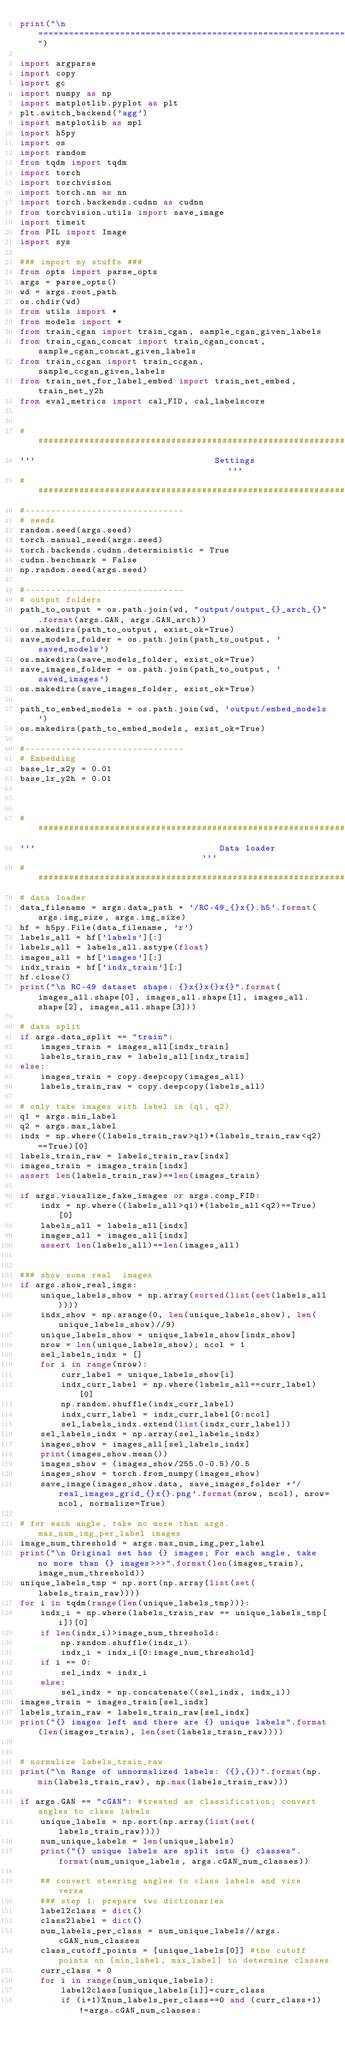Convert code to text. <code><loc_0><loc_0><loc_500><loc_500><_Python_>print("\n===================================================================================================")

import argparse
import copy
import gc
import numpy as np
import matplotlib.pyplot as plt
plt.switch_backend('agg')
import matplotlib as mpl
import h5py
import os
import random
from tqdm import tqdm
import torch
import torchvision
import torch.nn as nn
import torch.backends.cudnn as cudnn
from torchvision.utils import save_image
import timeit
from PIL import Image
import sys

### import my stuffs ###
from opts import parse_opts
args = parse_opts()
wd = args.root_path
os.chdir(wd)
from utils import *
from models import *
from train_cgan import train_cgan, sample_cgan_given_labels
from train_cgan_concat import train_cgan_concat, sample_cgan_concat_given_labels
from train_ccgan import train_ccgan, sample_ccgan_given_labels
from train_net_for_label_embed import train_net_embed, train_net_y2h
from eval_metrics import cal_FID, cal_labelscore


#######################################################################################
'''                                   Settings                                      '''
#######################################################################################
#-------------------------------
# seeds
random.seed(args.seed)
torch.manual_seed(args.seed)
torch.backends.cudnn.deterministic = True
cudnn.benchmark = False
np.random.seed(args.seed)

#-------------------------------
# output folders
path_to_output = os.path.join(wd, "output/output_{}_arch_{}".format(args.GAN, args.GAN_arch))
os.makedirs(path_to_output, exist_ok=True)
save_models_folder = os.path.join(path_to_output, 'saved_models')
os.makedirs(save_models_folder, exist_ok=True)
save_images_folder = os.path.join(path_to_output, 'saved_images')
os.makedirs(save_images_folder, exist_ok=True)

path_to_embed_models = os.path.join(wd, 'output/embed_models')
os.makedirs(path_to_embed_models, exist_ok=True)

#-------------------------------
# Embedding
base_lr_x2y = 0.01
base_lr_y2h = 0.01



#######################################################################################
'''                                    Data loader                                 '''
#######################################################################################
# data loader
data_filename = args.data_path + '/RC-49_{}x{}.h5'.format(args.img_size, args.img_size)
hf = h5py.File(data_filename, 'r')
labels_all = hf['labels'][:]
labels_all = labels_all.astype(float)
images_all = hf['images'][:]
indx_train = hf['indx_train'][:]
hf.close()
print("\n RC-49 dataset shape: {}x{}x{}x{}".format(images_all.shape[0], images_all.shape[1], images_all.shape[2], images_all.shape[3]))

# data split
if args.data_split == "train":
    images_train = images_all[indx_train]
    labels_train_raw = labels_all[indx_train]
else:
    images_train = copy.deepcopy(images_all)
    labels_train_raw = copy.deepcopy(labels_all)

# only take images with label in (q1, q2)
q1 = args.min_label
q2 = args.max_label
indx = np.where((labels_train_raw>q1)*(labels_train_raw<q2)==True)[0]
labels_train_raw = labels_train_raw[indx]
images_train = images_train[indx]
assert len(labels_train_raw)==len(images_train)

if args.visualize_fake_images or args.comp_FID:
    indx = np.where((labels_all>q1)*(labels_all<q2)==True)[0]
    labels_all = labels_all[indx]
    images_all = images_all[indx]
    assert len(labels_all)==len(images_all)


### show some real  images
if args.show_real_imgs:
    unique_labels_show = np.array(sorted(list(set(labels_all))))
    indx_show = np.arange(0, len(unique_labels_show), len(unique_labels_show)//9)
    unique_labels_show = unique_labels_show[indx_show]
    nrow = len(unique_labels_show); ncol = 1
    sel_labels_indx = []
    for i in range(nrow):
        curr_label = unique_labels_show[i]
        indx_curr_label = np.where(labels_all==curr_label)[0]
        np.random.shuffle(indx_curr_label)
        indx_curr_label = indx_curr_label[0:ncol]
        sel_labels_indx.extend(list(indx_curr_label))
    sel_labels_indx = np.array(sel_labels_indx)
    images_show = images_all[sel_labels_indx]
    print(images_show.mean())
    images_show = (images_show/255.0-0.5)/0.5
    images_show = torch.from_numpy(images_show)
    save_image(images_show.data, save_images_folder +'/real_images_grid_{}x{}.png'.format(nrow, ncol), nrow=ncol, normalize=True)

# for each angle, take no more than args.max_num_img_per_label images
image_num_threshold = args.max_num_img_per_label
print("\n Original set has {} images; For each angle, take no more than {} images>>>".format(len(images_train), image_num_threshold))
unique_labels_tmp = np.sort(np.array(list(set(labels_train_raw))))
for i in tqdm(range(len(unique_labels_tmp))):
    indx_i = np.where(labels_train_raw == unique_labels_tmp[i])[0]
    if len(indx_i)>image_num_threshold:
        np.random.shuffle(indx_i)
        indx_i = indx_i[0:image_num_threshold]
    if i == 0:
        sel_indx = indx_i
    else:
        sel_indx = np.concatenate((sel_indx, indx_i))
images_train = images_train[sel_indx]
labels_train_raw = labels_train_raw[sel_indx]
print("{} images left and there are {} unique labels".format(len(images_train), len(set(labels_train_raw))))


# normalize labels_train_raw
print("\n Range of unnormalized labels: ({},{})".format(np.min(labels_train_raw), np.max(labels_train_raw)))

if args.GAN == "cGAN": #treated as classification; convert angles to class labels
    unique_labels = np.sort(np.array(list(set(labels_train_raw))))
    num_unique_labels = len(unique_labels)
    print("{} unique labels are split into {} classes".format(num_unique_labels, args.cGAN_num_classes))

    ## convert steering angles to class labels and vice versa
    ### step 1: prepare two dictionaries
    label2class = dict()
    class2label = dict()
    num_labels_per_class = num_unique_labels//args.cGAN_num_classes
    class_cutoff_points = [unique_labels[0]] #the cutoff points on [min_label, max_label] to determine classes
    curr_class = 0
    for i in range(num_unique_labels):
        label2class[unique_labels[i]]=curr_class
        if (i+1)%num_labels_per_class==0 and (curr_class+1)!=args.cGAN_num_classes:</code> 